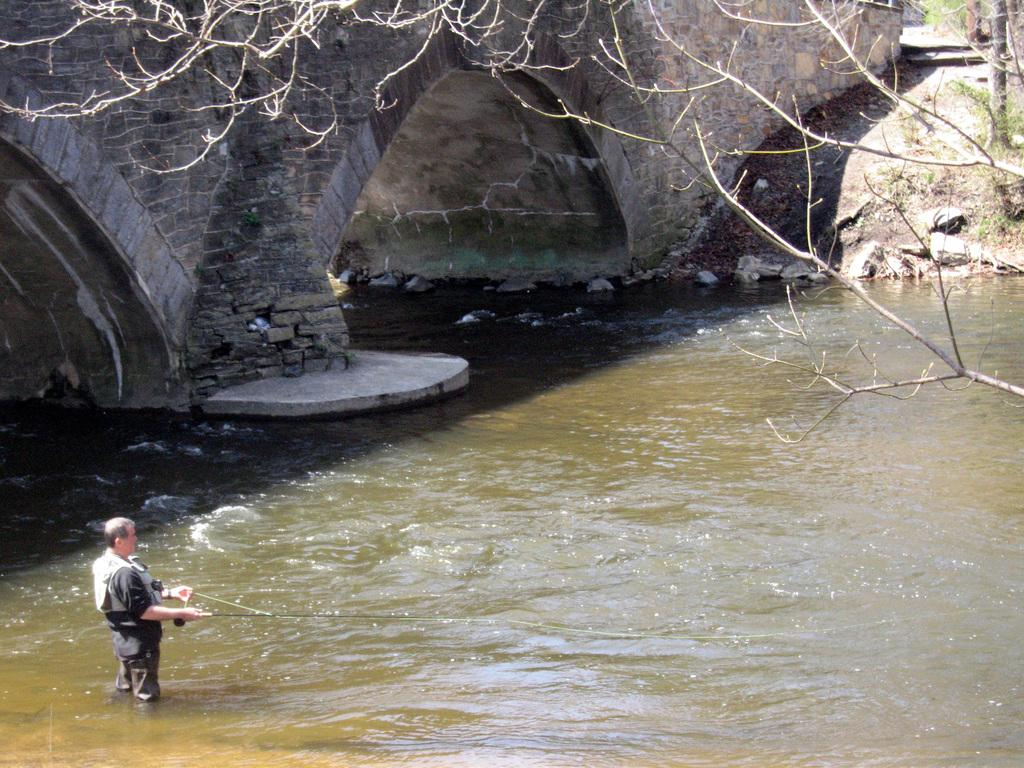What is the man in the image doing in the water? The man is standing in the water on the left side of the image, and he is fishing. What is the man wearing in the image? The man is wearing a black dress in the image. What can be seen in the background of the image? There appears to be a bridge in the image, and there is a tree on the right side of the image. What type of bead can be seen rolling down the bridge in the image? There is no bead present in the image, and no bead is rolling down the bridge. 